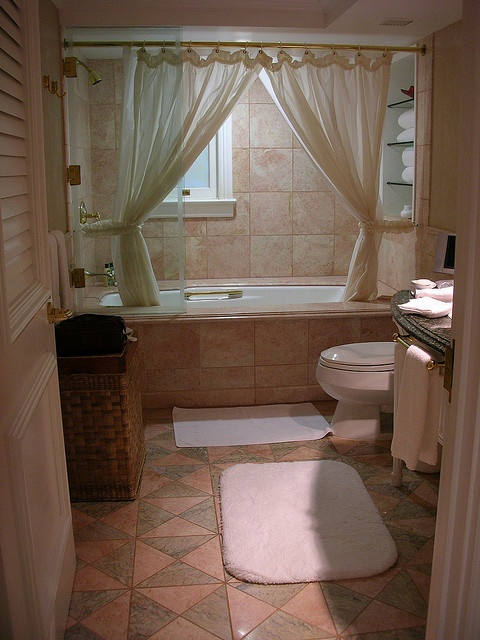Describe the objects in this image and their specific colors. I can see toilet in black, gray, and maroon tones and sink in black and gray tones in this image. 